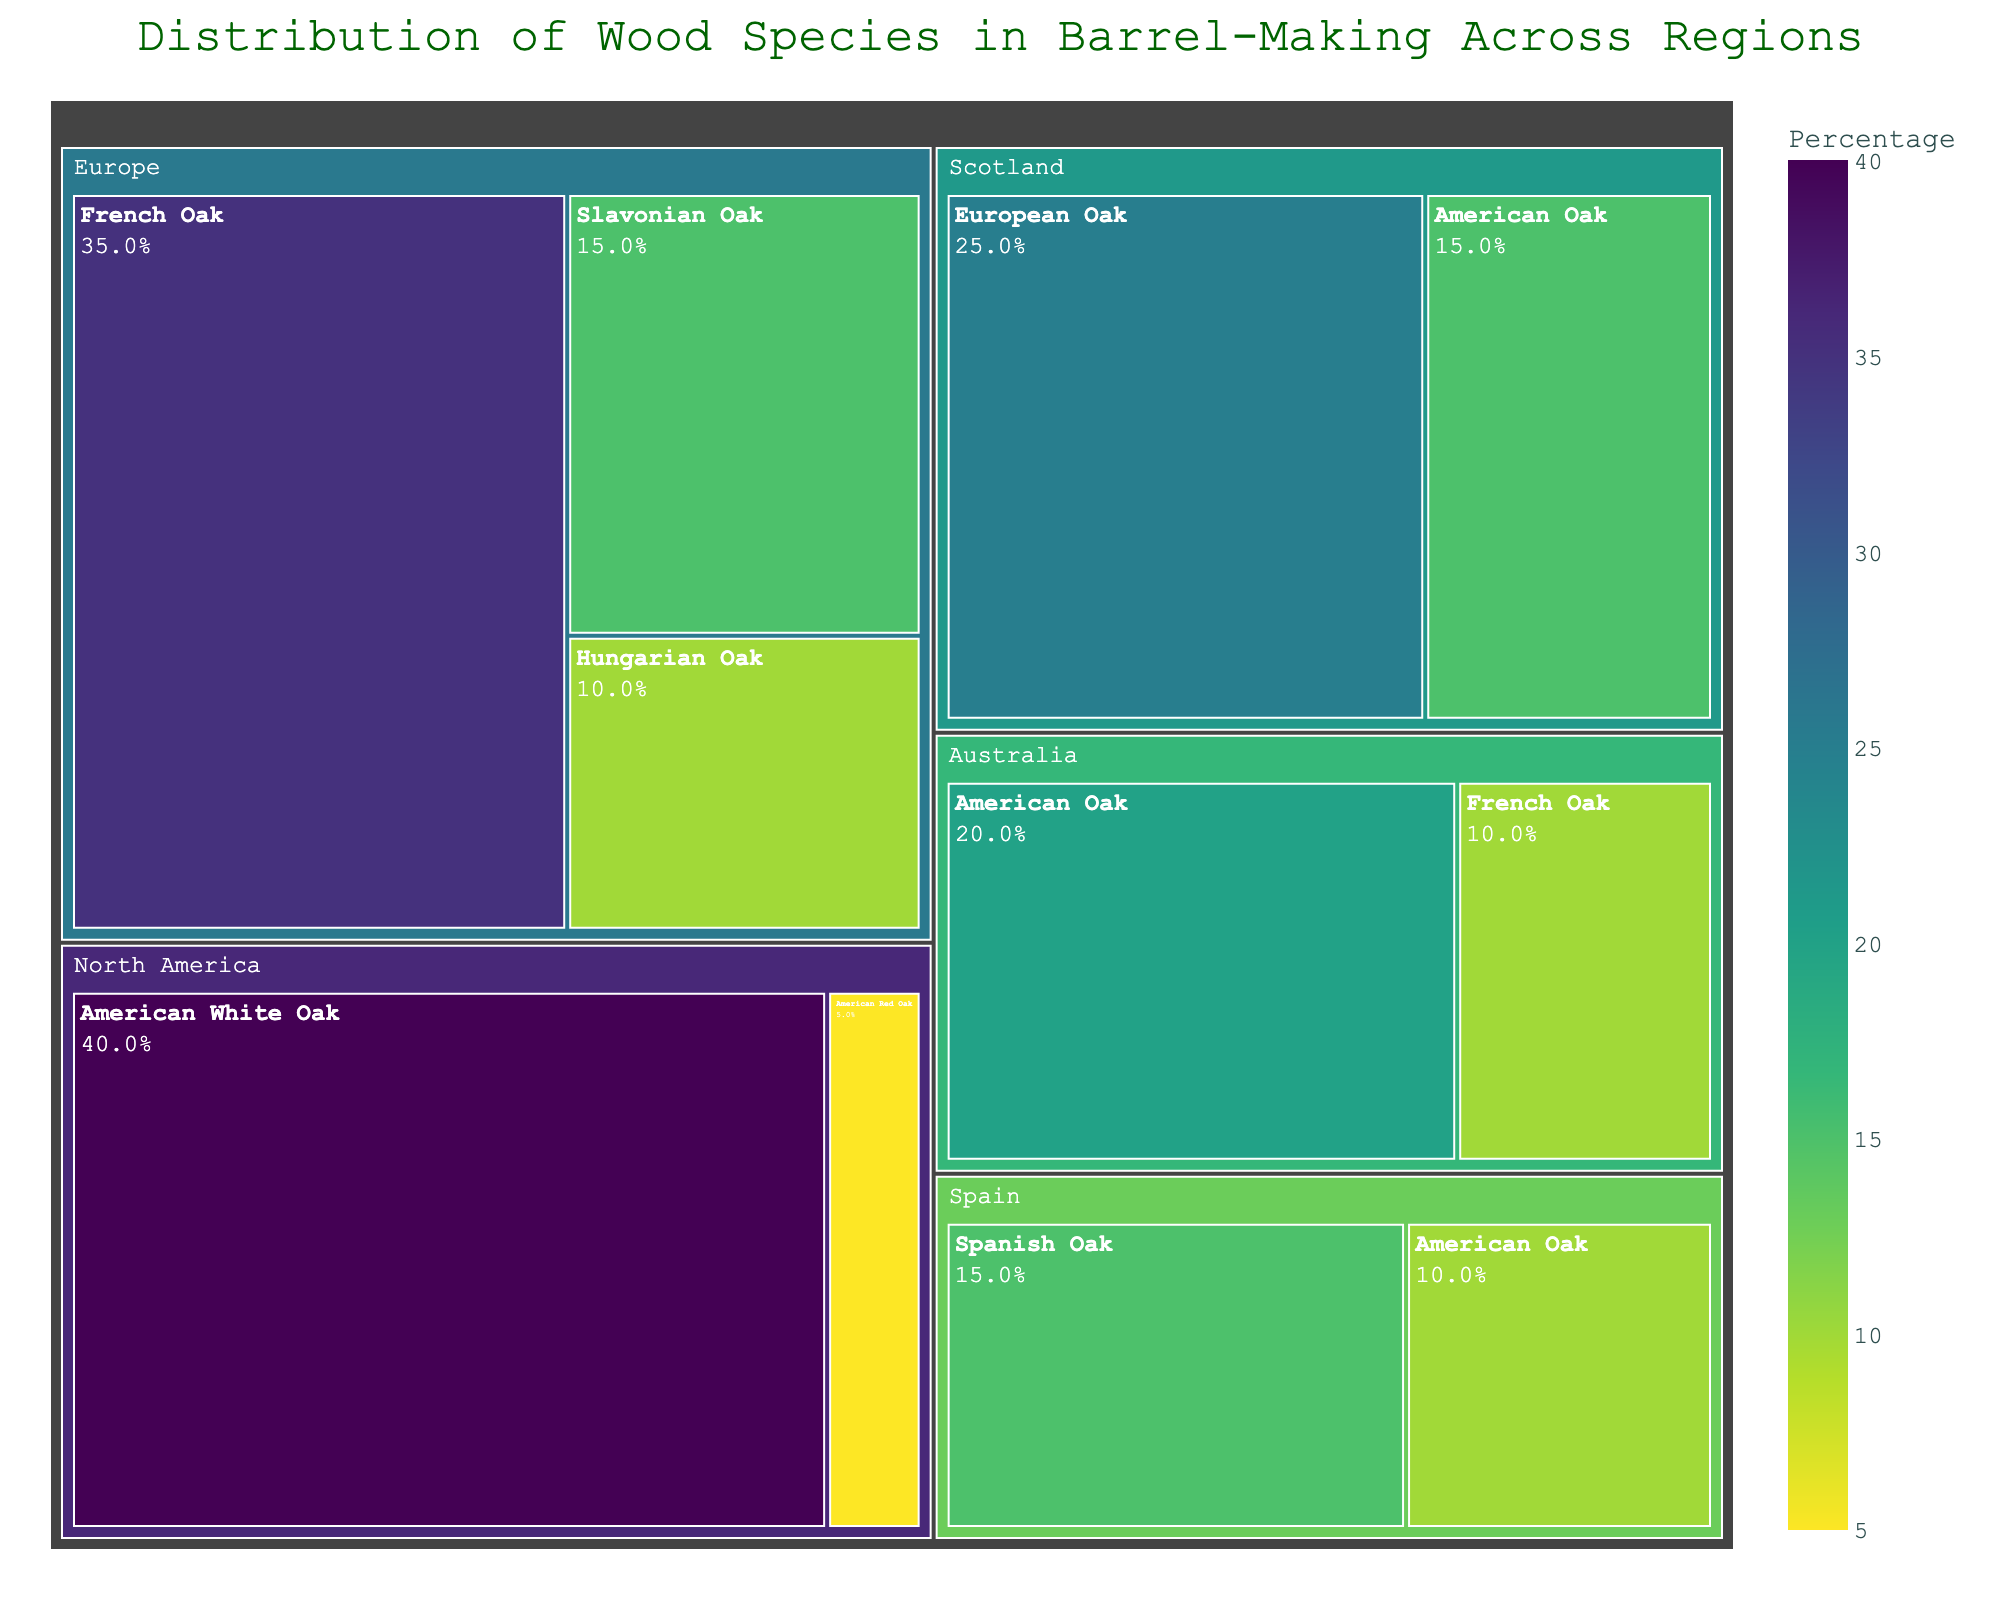Which region uses the highest percentage of French Oak? The figure shows regions as the first-level categories and wood species as the second-level categories, with percentages indicating usage. By examining the figure, we can see that Europe has the highest percentage of French Oak at 35%.
Answer: Europe What is the combined percentage of American Oaks used in North America and Australia? In North America, the percentages for American White Oak and American Red Oak are 40% and 5%, respectively. In Australia, American Oak is 20%. The combined percentage is 40 + 5 + 20 = 65%.
Answer: 65% Which wood species is predominantly used in Scotland? The treemap shows both European Oak and American Oak under the Scotland region. European Oak has a higher percentage of 25% compared to American Oak's 15%. Therefore, European Oak is predominantly used.
Answer: European Oak How does the usage of French Oak in Europe compare to its usage in Australia? From the treemap, we see the percentages for French Oak in Europe and Australia are 35% and 10%, respectively. French Oak usage in Europe is higher by 25% compared to Australia.
Answer: Europe uses 25% more What is the least used wood species in barrel-making across all regions? By surveying the treemap, the least used wood species with the smallest percentages of usage are Hungarian Oak in Europe at 10% and American Red Oak in North America at 5%. American Red Oak is the least used with 5%.
Answer: American Red Oak What is the most used wood species in barrel-making in North America? The figure indicates two categories under North America: American White Oak (40%) and American Red Oak (5%). American White Oak has the highest percentage.
Answer: American White Oak Calculate the total percentage of all wood species used in Spain. Spain's part of the treemap shows two categories: Spanish Oak (15%) and American Oak (10%). The total percentage is 15 + 10 = 25%.
Answer: 25% Which region uses the highest percentage of European Oak (French, Slavonian, Hungarian)? European Oaks are distributed as French Oak (35%), Slavonian Oak (15%), and Hungarian Oak (10%) in Europe. Europe has the highest combined usage of European Oaks at 35 + 15 + 10 = 60%.
Answer: Europe Between American Oak and European Oak, which is more frequently used in barrel-making in Scotland? The treemap for Scotland shows European Oak at 25% and American Oak at 15%. European Oak is used more frequently in Scotland.
Answer: European Oak In which region is the diversity of wood species (number of different wood species) the highest? Reviewing the treemap, the region with the most wood species listed is Europe, having three different species: French Oak, Slavonian Oak, and Hungarian Oak.
Answer: Europe 